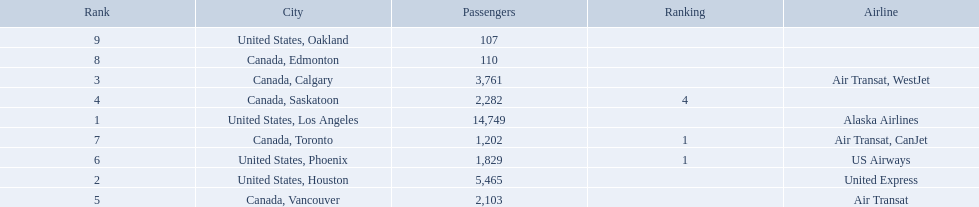What are the cities that are associated with the playa de oro international airport? United States, Los Angeles, United States, Houston, Canada, Calgary, Canada, Saskatoon, Canada, Vancouver, United States, Phoenix, Canada, Toronto, Canada, Edmonton, United States, Oakland. What is uniteed states, los angeles passenger count? 14,749. What other cities passenger count would lead to 19,000 roughly when combined with previous los angeles? Canada, Calgary. 